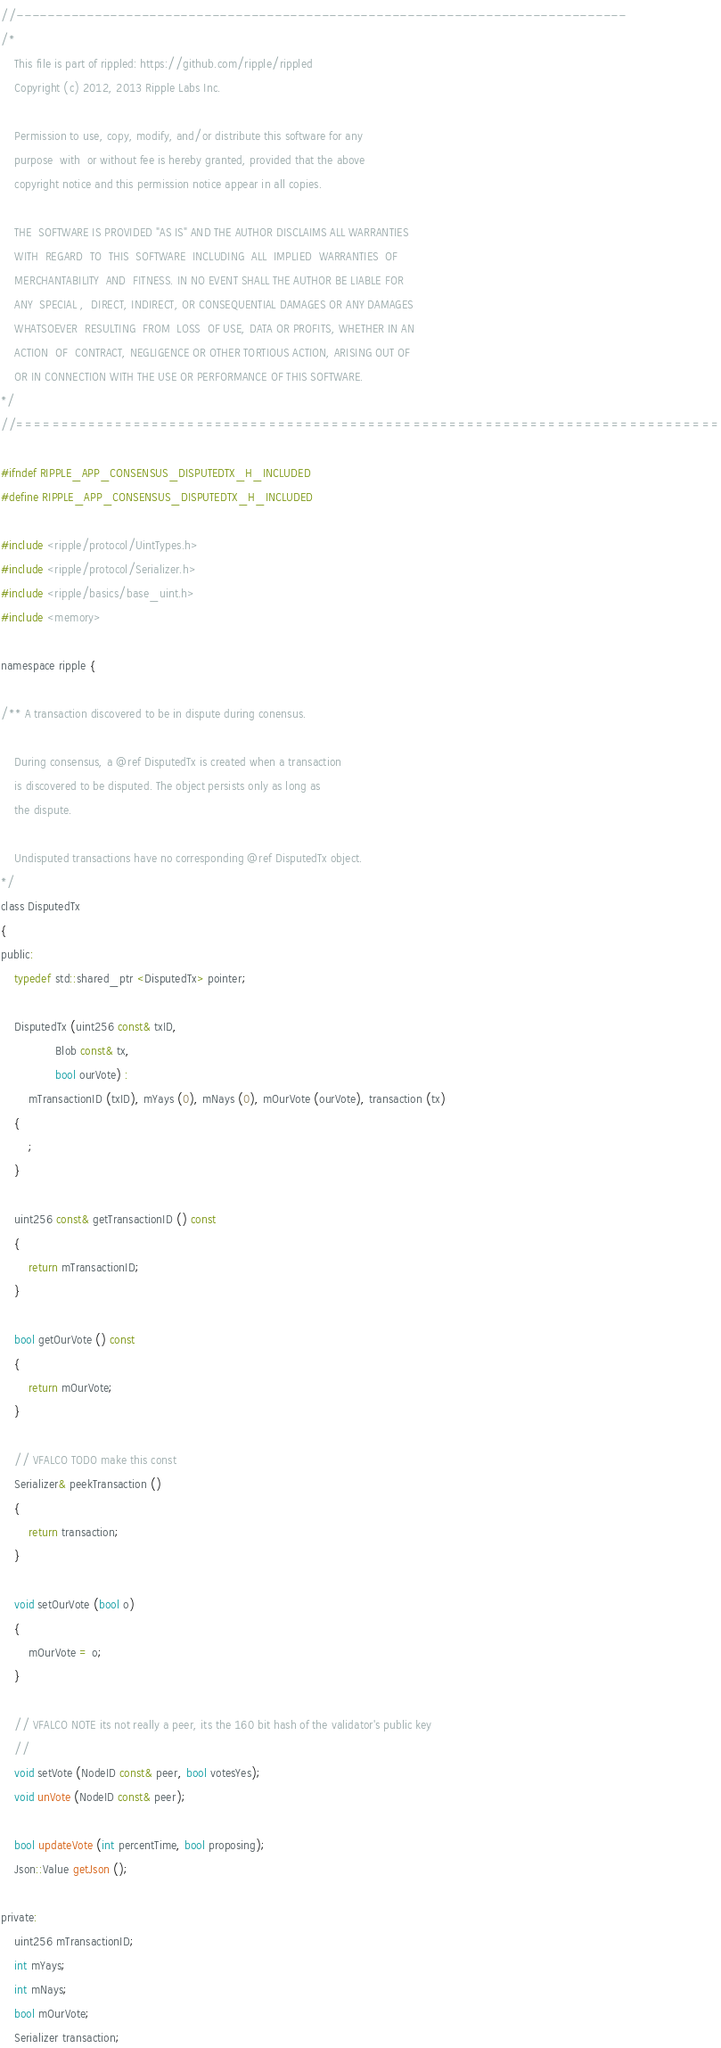Convert code to text. <code><loc_0><loc_0><loc_500><loc_500><_C_>//------------------------------------------------------------------------------
/*
    This file is part of rippled: https://github.com/ripple/rippled
    Copyright (c) 2012, 2013 Ripple Labs Inc.

    Permission to use, copy, modify, and/or distribute this software for any
    purpose  with  or without fee is hereby granted, provided that the above
    copyright notice and this permission notice appear in all copies.

    THE  SOFTWARE IS PROVIDED "AS IS" AND THE AUTHOR DISCLAIMS ALL WARRANTIES
    WITH  REGARD  TO  THIS  SOFTWARE  INCLUDING  ALL  IMPLIED  WARRANTIES  OF
    MERCHANTABILITY  AND  FITNESS. IN NO EVENT SHALL THE AUTHOR BE LIABLE FOR
    ANY  SPECIAL ,  DIRECT, INDIRECT, OR CONSEQUENTIAL DAMAGES OR ANY DAMAGES
    WHATSOEVER  RESULTING  FROM  LOSS  OF USE, DATA OR PROFITS, WHETHER IN AN
    ACTION  OF  CONTRACT, NEGLIGENCE OR OTHER TORTIOUS ACTION, ARISING OUT OF
    OR IN CONNECTION WITH THE USE OR PERFORMANCE OF THIS SOFTWARE.
*/
//==============================================================================

#ifndef RIPPLE_APP_CONSENSUS_DISPUTEDTX_H_INCLUDED
#define RIPPLE_APP_CONSENSUS_DISPUTEDTX_H_INCLUDED

#include <ripple/protocol/UintTypes.h>
#include <ripple/protocol/Serializer.h>
#include <ripple/basics/base_uint.h>
#include <memory>

namespace ripple {

/** A transaction discovered to be in dispute during conensus.

    During consensus, a @ref DisputedTx is created when a transaction
    is discovered to be disputed. The object persists only as long as
    the dispute.

    Undisputed transactions have no corresponding @ref DisputedTx object.
*/
class DisputedTx
{
public:
    typedef std::shared_ptr <DisputedTx> pointer;

    DisputedTx (uint256 const& txID,
                Blob const& tx,
                bool ourVote) :
        mTransactionID (txID), mYays (0), mNays (0), mOurVote (ourVote), transaction (tx)
    {
        ;
    }

    uint256 const& getTransactionID () const
    {
        return mTransactionID;
    }

    bool getOurVote () const
    {
        return mOurVote;
    }

    // VFALCO TODO make this const
    Serializer& peekTransaction ()
    {
        return transaction;
    }

    void setOurVote (bool o)
    {
        mOurVote = o;
    }

    // VFALCO NOTE its not really a peer, its the 160 bit hash of the validator's public key
    //
    void setVote (NodeID const& peer, bool votesYes);
    void unVote (NodeID const& peer);

    bool updateVote (int percentTime, bool proposing);
    Json::Value getJson ();

private:
    uint256 mTransactionID;
    int mYays;
    int mNays;
    bool mOurVote;
    Serializer transaction;
</code> 